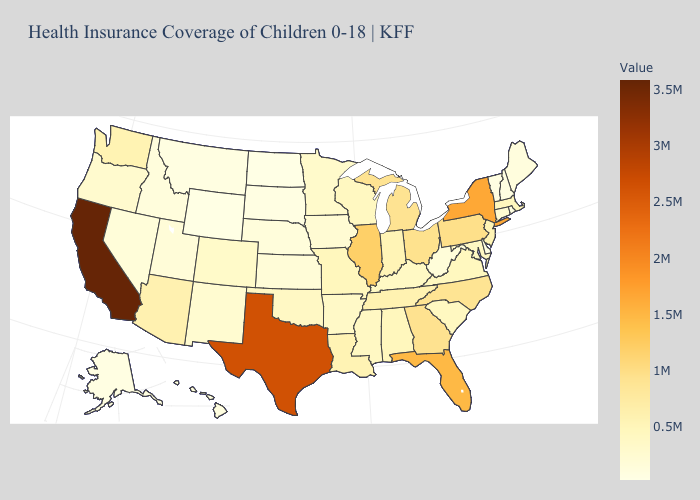Which states have the lowest value in the South?
Concise answer only. Delaware. Among the states that border North Dakota , does South Dakota have the highest value?
Give a very brief answer. No. Does North Dakota have the lowest value in the USA?
Concise answer only. Yes. 